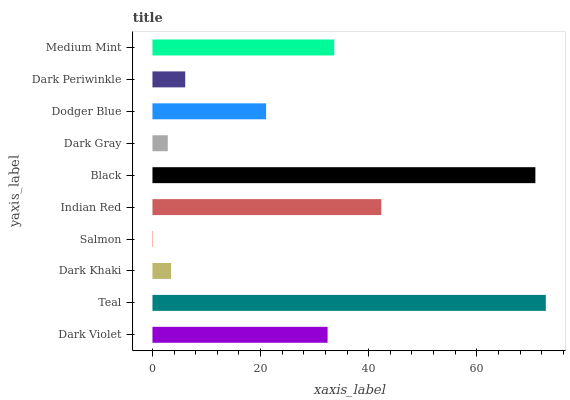Is Salmon the minimum?
Answer yes or no. Yes. Is Teal the maximum?
Answer yes or no. Yes. Is Dark Khaki the minimum?
Answer yes or no. No. Is Dark Khaki the maximum?
Answer yes or no. No. Is Teal greater than Dark Khaki?
Answer yes or no. Yes. Is Dark Khaki less than Teal?
Answer yes or no. Yes. Is Dark Khaki greater than Teal?
Answer yes or no. No. Is Teal less than Dark Khaki?
Answer yes or no. No. Is Dark Violet the high median?
Answer yes or no. Yes. Is Dodger Blue the low median?
Answer yes or no. Yes. Is Dark Gray the high median?
Answer yes or no. No. Is Teal the low median?
Answer yes or no. No. 